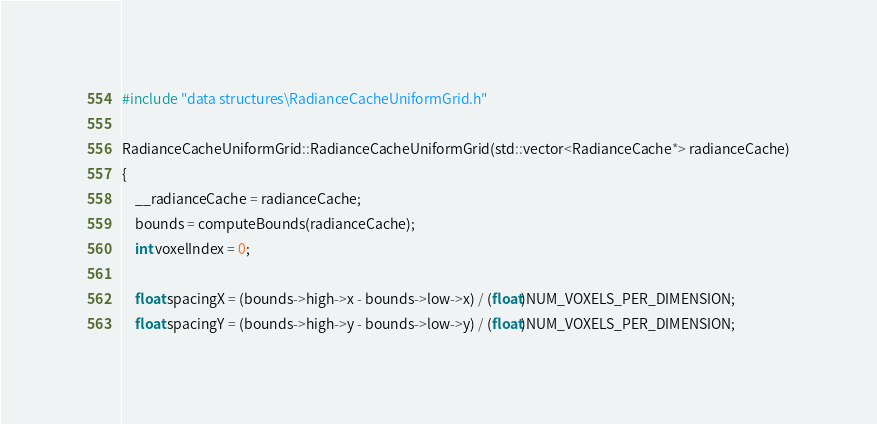Convert code to text. <code><loc_0><loc_0><loc_500><loc_500><_C++_>#include "data structures\RadianceCacheUniformGrid.h"

RadianceCacheUniformGrid::RadianceCacheUniformGrid(std::vector<RadianceCache*> radianceCache)
{
	__radianceCache = radianceCache;
	bounds = computeBounds(radianceCache);
	int voxelIndex = 0;

	float spacingX = (bounds->high->x - bounds->low->x) / (float)NUM_VOXELS_PER_DIMENSION;
	float spacingY = (bounds->high->y - bounds->low->y) / (float)NUM_VOXELS_PER_DIMENSION;</code> 